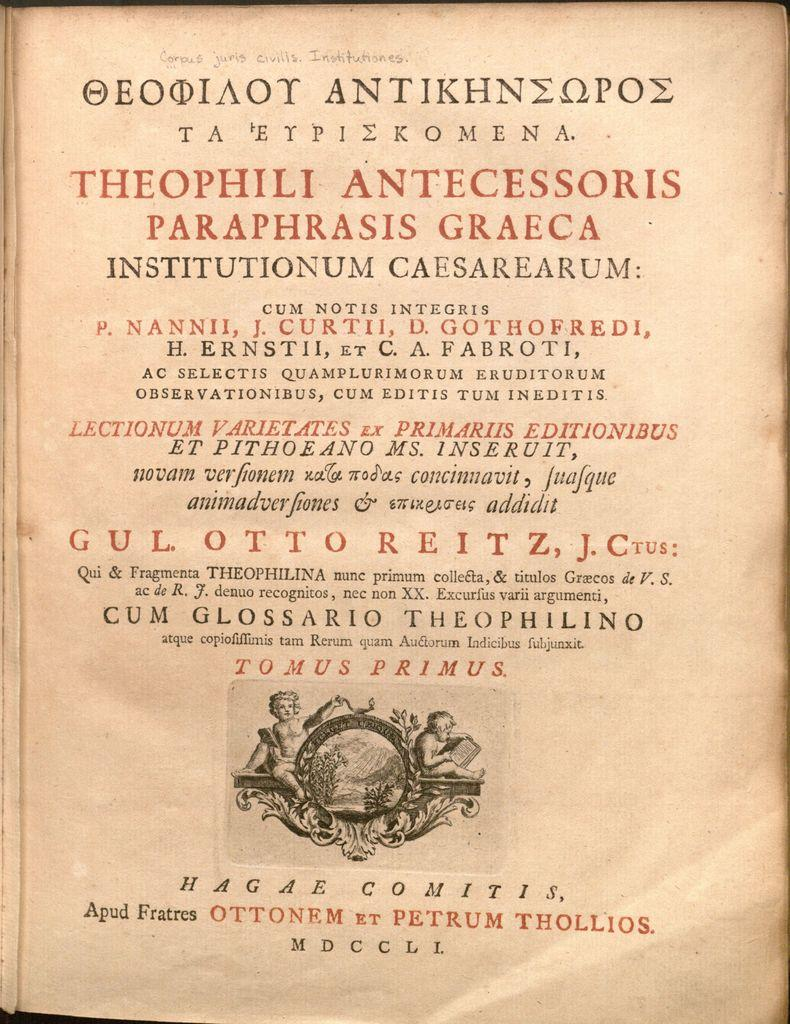What is present on the paper in the image? There is text on the paper in the image. What else can be seen in the image besides the paper? There are people in the image. What type of elbow is visible on the map in the image? There is no map or elbow present in the image; it only features a paper with text and people. 